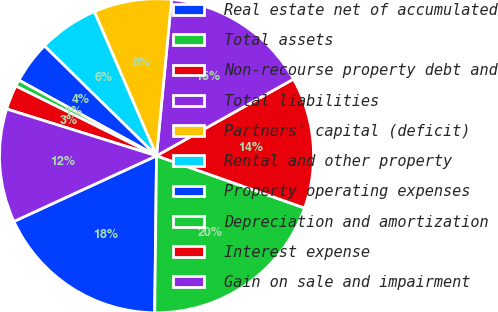<chart> <loc_0><loc_0><loc_500><loc_500><pie_chart><fcel>Real estate net of accumulated<fcel>Total assets<fcel>Non-recourse property debt and<fcel>Total liabilities<fcel>Partners' capital (deficit)<fcel>Rental and other property<fcel>Property operating expenses<fcel>Depreciation and amortization<fcel>Interest expense<fcel>Gain on sale and impairment<nl><fcel>17.95%<fcel>19.79%<fcel>13.52%<fcel>15.35%<fcel>8.01%<fcel>6.18%<fcel>4.34%<fcel>0.67%<fcel>2.51%<fcel>11.68%<nl></chart> 